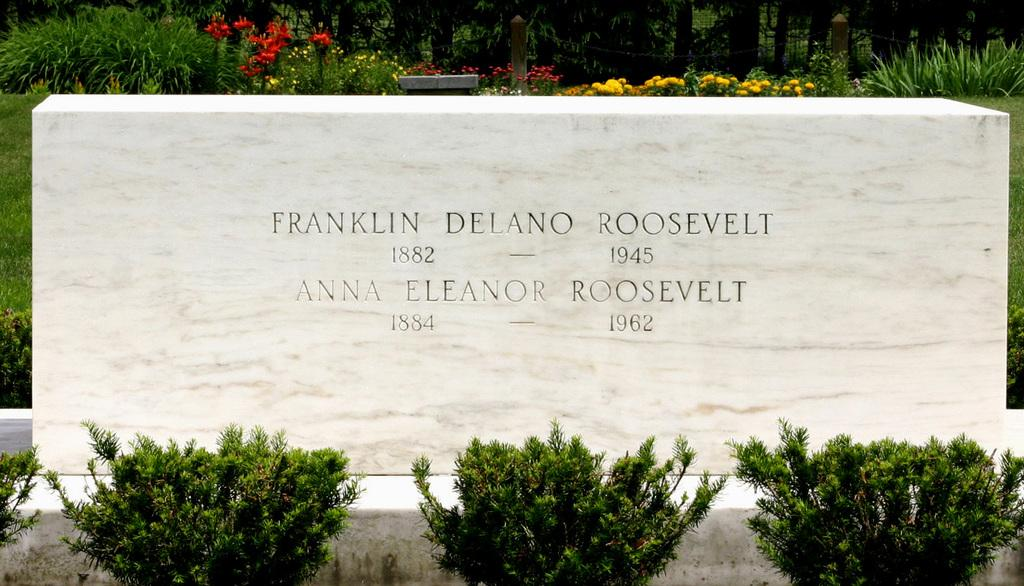What type of structure is visible in the image? There is a laid stone in the image. What type of vegetation can be seen in the image? There are bushes, flowers, trees, and shrubs in the image. What other man-made structures are present in the image? There is a fence and poles in the image. How many sisters are sitting on the laid stone in the image? There are no sisters present in the image; it features a laid stone, bushes, flowers, trees, shrubs, a fence, and poles. What type of lunch is being served on the laid stone in the image? There is no lunch present in the image; it features a laid stone, bushes, flowers, trees, shrubs, a fence, and poles. 